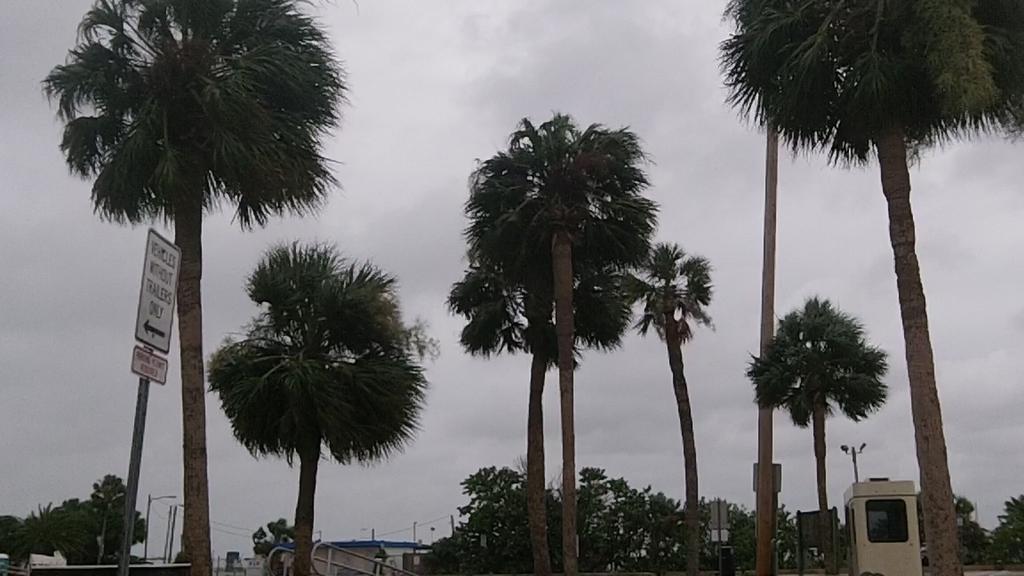Can you describe this image briefly? This picture was taken from the outside. In this picture at front there are trees. At the left side of the image there is a direction pole. On right side of the image there are some boards. At the background there are buildings and at the top there is sky. 